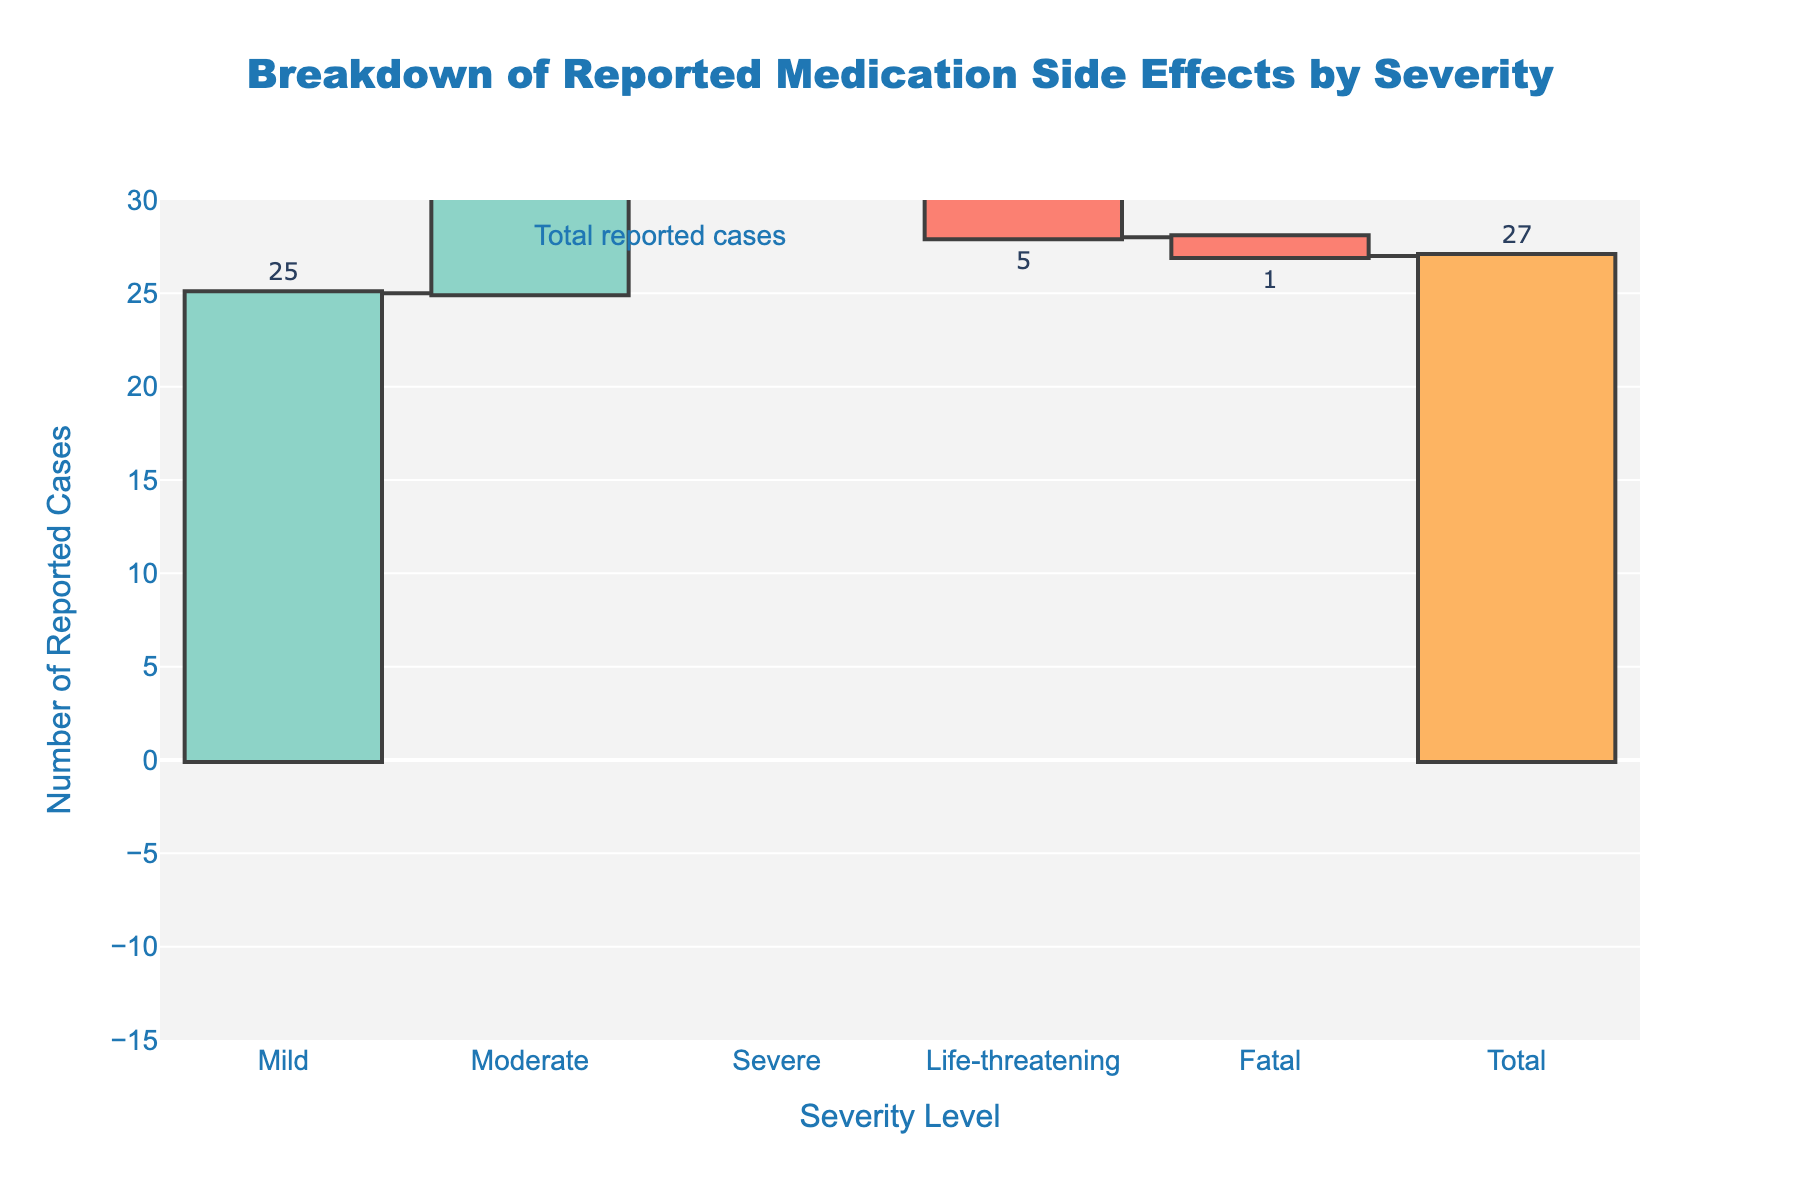How many total reported cases of medication side effects are shown in the chart? The title and annotation indicate that the total number of reported cases is shown at the end of the chart. The annotation next to the final bar, labeled "Total reported cases," confirms this number.
Answer: 27 How many cases were reported as life-threatening? Look at the bar labeled "Life-threatening." The text above it indicates the number of reported cases.
Answer: 5 Which severity level had the highest number of reported cases? By comparing the heights of the bars and the values shown, the "Mild" bar is the tallest and has the highest value.
Answer: Mild What is the sum of moderate and severe cases? Moderate cases are 18 and severe cases are -10, so sum them up: 18 + (-10) = 8.
Answer: 8 Were there more mild or moderate cases reported? Compare the values for Mild (25) and Moderate (18). Since 25 is greater than 18, there were more mild cases.
Answer: Mild What is the net difference between severe and life-threatening cases? Severe cases are -10, and life-threatening cases are -5. Their net difference is -10 - (-5) = -5.
Answer: -5 How many more mild cases were there compared to fatal cases? There are 25 mild cases and 1 fatal case. The difference is 25 - 1 = 24.
Answer: 24 Is the value for severe cases positive or negative? The value shown for the "Severe" severity level is -10, which indicates this is a negative value.
Answer: Negative What is the range of the y-axis in the chart? The y-axis scales from -15 to 30, as given in the y-axis attributes of the chart.
Answer: -15 to 30 